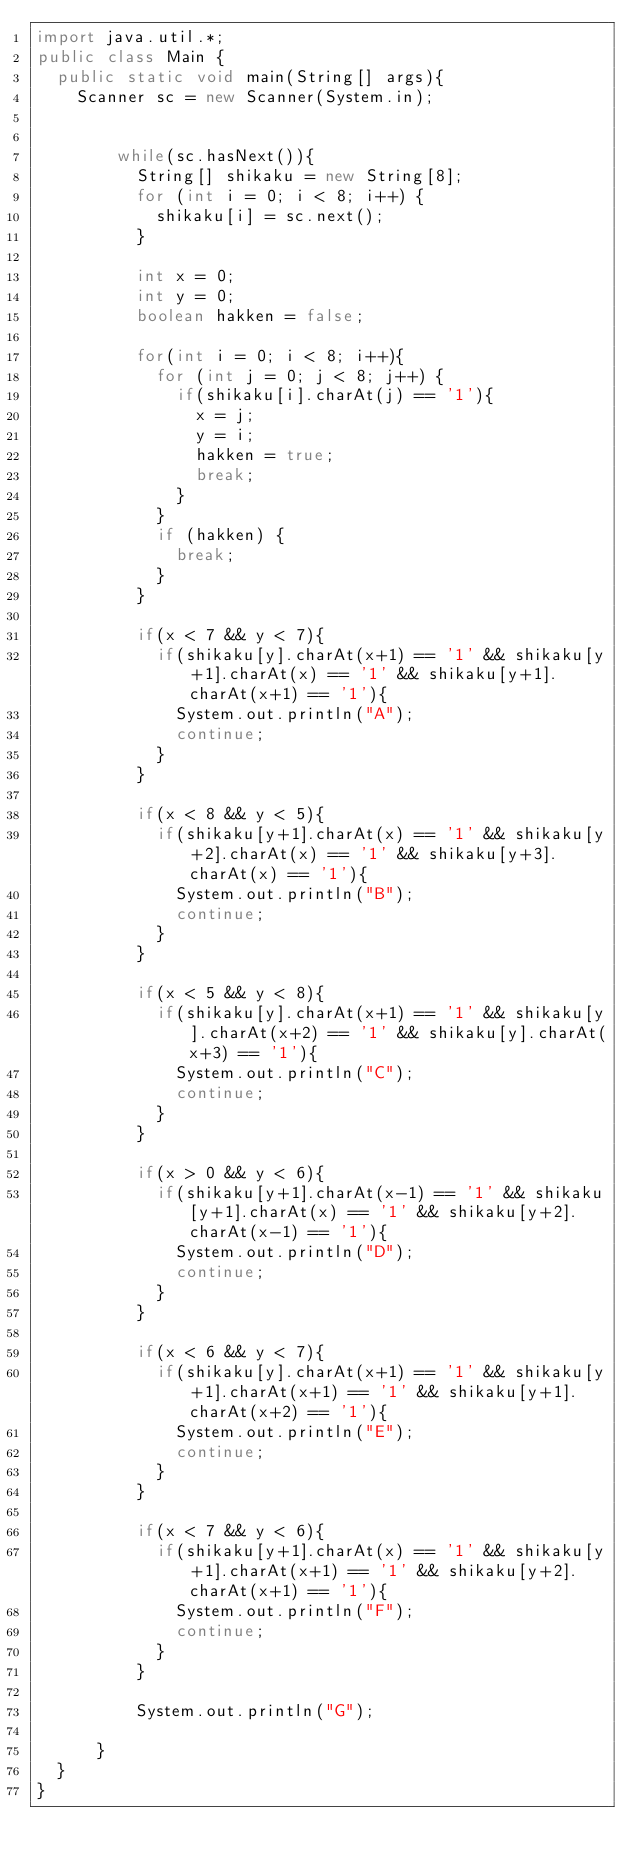Convert code to text. <code><loc_0><loc_0><loc_500><loc_500><_Java_>import java.util.*;
public class Main {
	public static void main(String[] args){
		Scanner sc = new Scanner(System.in);
 

        while(sc.hasNext()){
        	String[] shikaku = new String[8];
        	for (int i = 0; i < 8; i++) {
        		shikaku[i] = sc.next();
        	}

        	int x = 0;
        	int y = 0;
        	boolean hakken = false;

        	for(int i = 0; i < 8; i++){
        		for (int j = 0; j < 8; j++) {
        			if(shikaku[i].charAt(j) == '1'){
        				x = j;
        				y = i;
        				hakken = true;
        				break;
        			}
        		}
        		if (hakken) {
        			break;
        		}
        	} 

        	if(x < 7 && y < 7){
        		if(shikaku[y].charAt(x+1) == '1' && shikaku[y+1].charAt(x) == '1' && shikaku[y+1].charAt(x+1) == '1'){
        			System.out.println("A");
        			continue;
        		}
        	}

        	if(x < 8 && y < 5){
        		if(shikaku[y+1].charAt(x) == '1' && shikaku[y+2].charAt(x) == '1' && shikaku[y+3].charAt(x) == '1'){
        			System.out.println("B");
        			continue;
        		}
        	}

        	if(x < 5 && y < 8){
        		if(shikaku[y].charAt(x+1) == '1' && shikaku[y].charAt(x+2) == '1' && shikaku[y].charAt(x+3) == '1'){
        			System.out.println("C");
        			continue;
        		}
        	}

        	if(x > 0 && y < 6){
        		if(shikaku[y+1].charAt(x-1) == '1' && shikaku[y+1].charAt(x) == '1' && shikaku[y+2].charAt(x-1) == '1'){
        			System.out.println("D");
        			continue;
        		}
        	}

        	if(x < 6 && y < 7){
        		if(shikaku[y].charAt(x+1) == '1' && shikaku[y+1].charAt(x+1) == '1' && shikaku[y+1].charAt(x+2) == '1'){
        			System.out.println("E");
        			continue;
        		}
        	}

        	if(x < 7 && y < 6){
        		if(shikaku[y+1].charAt(x) == '1' && shikaku[y+1].charAt(x+1) == '1' && shikaku[y+2].charAt(x+1) == '1'){
        			System.out.println("F");
        			continue;
        		}
        	}

        	System.out.println("G");

    	}
	}
}</code> 